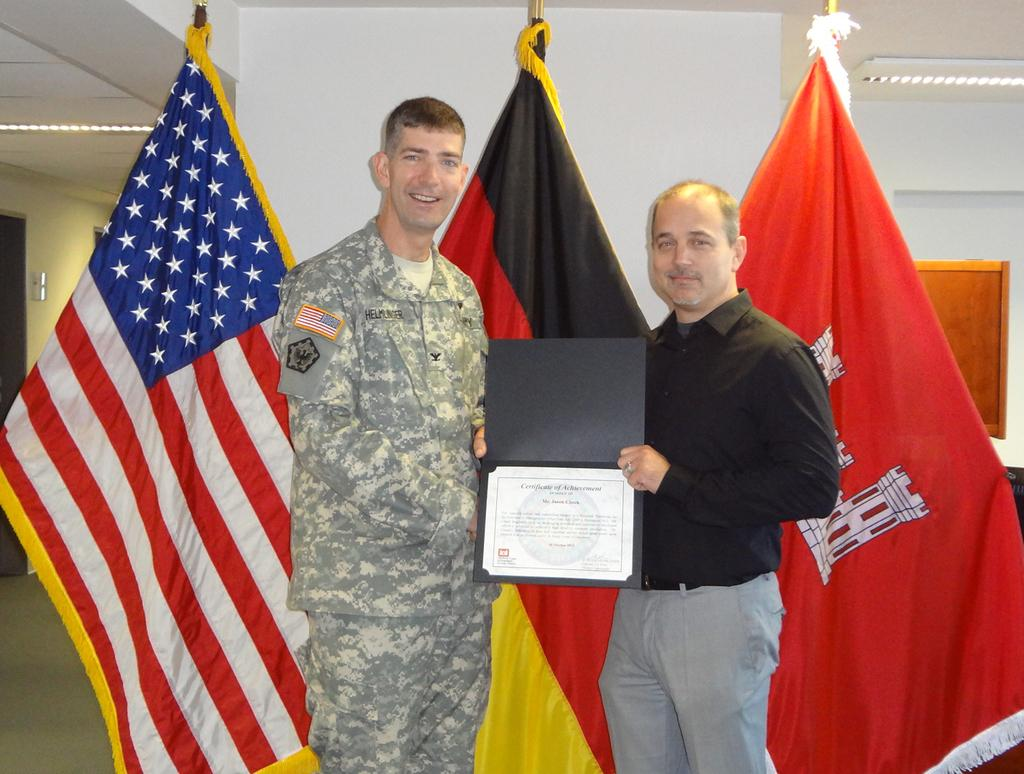<image>
Offer a succinct explanation of the picture presented. Two men pose in front of some flags while holding up a certificate of achievement. 